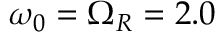Convert formula to latex. <formula><loc_0><loc_0><loc_500><loc_500>\omega _ { 0 } = \Omega _ { R } = 2 . 0</formula> 